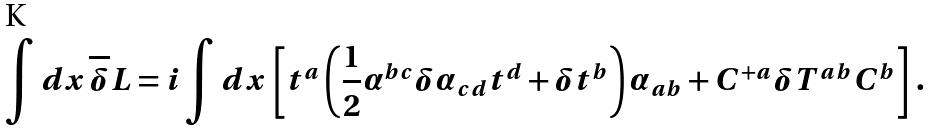<formula> <loc_0><loc_0><loc_500><loc_500>\int d x \, \overline { \delta } L = i \int d x \, \left [ t ^ { a } \left ( \frac { 1 } { 2 } \alpha ^ { b c } \delta \alpha _ { c d } t ^ { d } + \delta t ^ { b } \right ) \alpha _ { a b } + C ^ { + a } \delta T ^ { a b } C ^ { b } \right ] \, .</formula> 